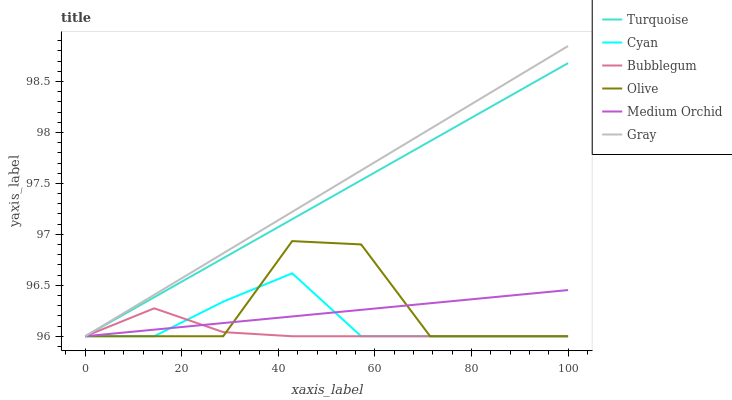Does Bubblegum have the minimum area under the curve?
Answer yes or no. Yes. Does Gray have the maximum area under the curve?
Answer yes or no. Yes. Does Turquoise have the minimum area under the curve?
Answer yes or no. No. Does Turquoise have the maximum area under the curve?
Answer yes or no. No. Is Gray the smoothest?
Answer yes or no. Yes. Is Olive the roughest?
Answer yes or no. Yes. Is Turquoise the smoothest?
Answer yes or no. No. Is Turquoise the roughest?
Answer yes or no. No. Does Gray have the lowest value?
Answer yes or no. Yes. Does Gray have the highest value?
Answer yes or no. Yes. Does Turquoise have the highest value?
Answer yes or no. No. Does Gray intersect Medium Orchid?
Answer yes or no. Yes. Is Gray less than Medium Orchid?
Answer yes or no. No. Is Gray greater than Medium Orchid?
Answer yes or no. No. 